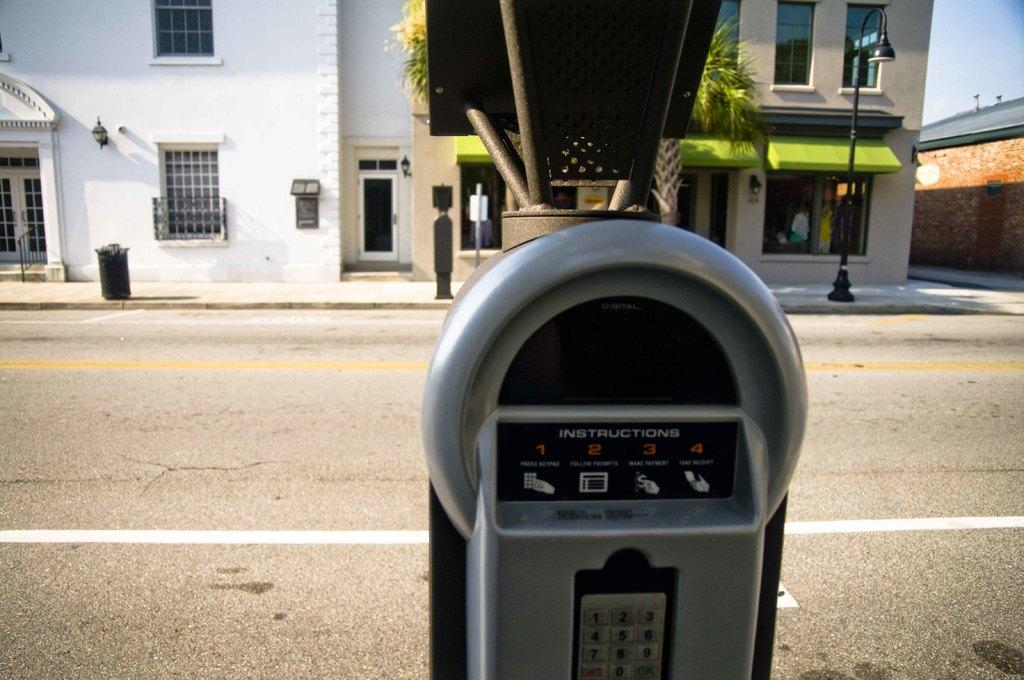Provide a one-sentence caption for the provided image. A parking meter that says instructions on it. 